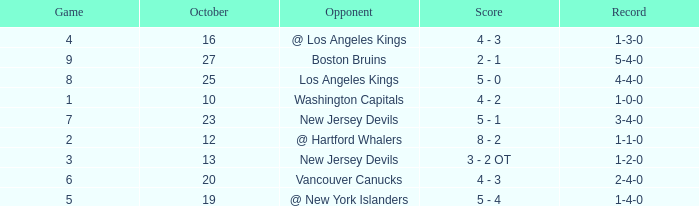Which game has the highest score in October with 9? 27.0. 